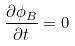Convert formula to latex. <formula><loc_0><loc_0><loc_500><loc_500>\frac { \partial \phi _ { B } } { \partial t } = 0</formula> 